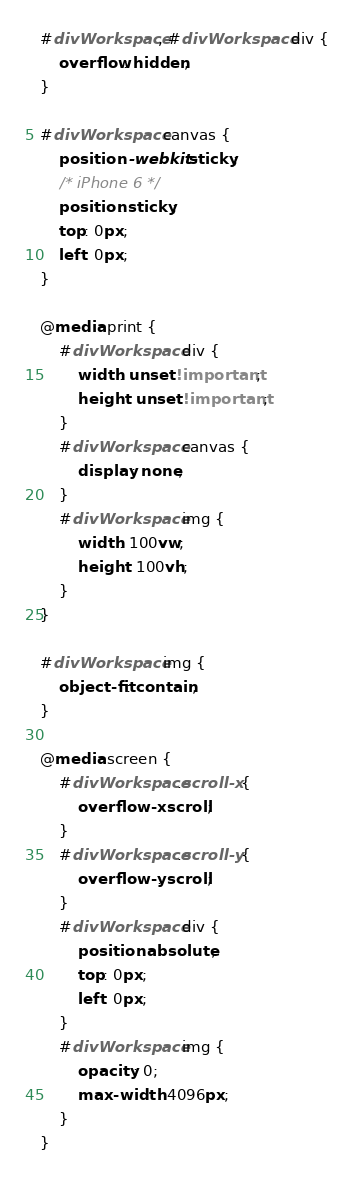<code> <loc_0><loc_0><loc_500><loc_500><_CSS_>#divWorkspace, #divWorkspace div {
	overflow: hidden;
}

#divWorkspace canvas {
	position: -webkit-sticky;
	/* iPhone 6 */
	position: sticky;
	top: 0px;
	left: 0px;
}

@media print {
	#divWorkspace div {
		width: unset !important;
		height: unset !important;
	}
	#divWorkspace canvas {
		display: none;
	}
	#divWorkspace img {
		width: 100vw;
		height: 100vh;
	}
}

#divWorkspace img {
	object-fit: contain;
}

@media screen {
	#divWorkspace.scroll-x {
		overflow-x: scroll;
	}
	#divWorkspace.scroll-y {
		overflow-y: scroll;
	}
	#divWorkspace div {
		position: absolute;
		top: 0px;
		left: 0px;
	}
	#divWorkspace img {
		opacity: 0;
		max-width: 4096px;
	}
}
</code> 